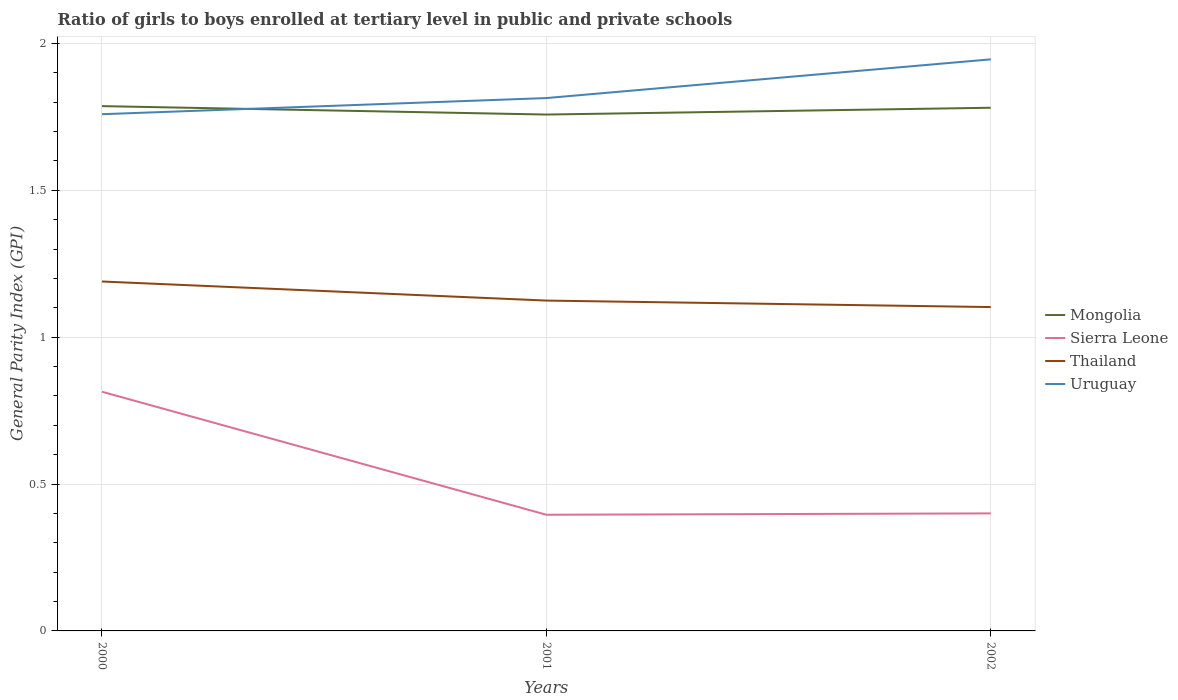How many different coloured lines are there?
Provide a succinct answer. 4. Does the line corresponding to Uruguay intersect with the line corresponding to Sierra Leone?
Offer a very short reply. No. Across all years, what is the maximum general parity index in Uruguay?
Your answer should be compact. 1.76. In which year was the general parity index in Sierra Leone maximum?
Make the answer very short. 2001. What is the total general parity index in Sierra Leone in the graph?
Provide a succinct answer. -0. What is the difference between the highest and the second highest general parity index in Uruguay?
Your answer should be compact. 0.19. What is the difference between the highest and the lowest general parity index in Thailand?
Your answer should be compact. 1. Is the general parity index in Sierra Leone strictly greater than the general parity index in Mongolia over the years?
Offer a terse response. Yes. How many lines are there?
Offer a terse response. 4. How many years are there in the graph?
Give a very brief answer. 3. Are the values on the major ticks of Y-axis written in scientific E-notation?
Make the answer very short. No. Does the graph contain grids?
Your answer should be very brief. Yes. What is the title of the graph?
Keep it short and to the point. Ratio of girls to boys enrolled at tertiary level in public and private schools. Does "Kazakhstan" appear as one of the legend labels in the graph?
Keep it short and to the point. No. What is the label or title of the Y-axis?
Ensure brevity in your answer.  General Parity Index (GPI). What is the General Parity Index (GPI) in Mongolia in 2000?
Make the answer very short. 1.79. What is the General Parity Index (GPI) of Sierra Leone in 2000?
Provide a succinct answer. 0.81. What is the General Parity Index (GPI) in Thailand in 2000?
Your answer should be very brief. 1.19. What is the General Parity Index (GPI) of Uruguay in 2000?
Ensure brevity in your answer.  1.76. What is the General Parity Index (GPI) in Mongolia in 2001?
Give a very brief answer. 1.76. What is the General Parity Index (GPI) in Sierra Leone in 2001?
Your answer should be very brief. 0.4. What is the General Parity Index (GPI) of Thailand in 2001?
Your answer should be very brief. 1.12. What is the General Parity Index (GPI) of Uruguay in 2001?
Make the answer very short. 1.81. What is the General Parity Index (GPI) of Mongolia in 2002?
Provide a short and direct response. 1.78. What is the General Parity Index (GPI) in Sierra Leone in 2002?
Make the answer very short. 0.4. What is the General Parity Index (GPI) in Thailand in 2002?
Ensure brevity in your answer.  1.1. What is the General Parity Index (GPI) in Uruguay in 2002?
Your answer should be very brief. 1.95. Across all years, what is the maximum General Parity Index (GPI) of Mongolia?
Offer a terse response. 1.79. Across all years, what is the maximum General Parity Index (GPI) in Sierra Leone?
Make the answer very short. 0.81. Across all years, what is the maximum General Parity Index (GPI) in Thailand?
Make the answer very short. 1.19. Across all years, what is the maximum General Parity Index (GPI) in Uruguay?
Provide a succinct answer. 1.95. Across all years, what is the minimum General Parity Index (GPI) in Mongolia?
Offer a terse response. 1.76. Across all years, what is the minimum General Parity Index (GPI) in Sierra Leone?
Provide a short and direct response. 0.4. Across all years, what is the minimum General Parity Index (GPI) in Thailand?
Offer a terse response. 1.1. Across all years, what is the minimum General Parity Index (GPI) in Uruguay?
Keep it short and to the point. 1.76. What is the total General Parity Index (GPI) of Mongolia in the graph?
Give a very brief answer. 5.32. What is the total General Parity Index (GPI) in Sierra Leone in the graph?
Give a very brief answer. 1.61. What is the total General Parity Index (GPI) of Thailand in the graph?
Provide a succinct answer. 3.42. What is the total General Parity Index (GPI) in Uruguay in the graph?
Your answer should be compact. 5.52. What is the difference between the General Parity Index (GPI) of Mongolia in 2000 and that in 2001?
Your answer should be compact. 0.03. What is the difference between the General Parity Index (GPI) in Sierra Leone in 2000 and that in 2001?
Provide a succinct answer. 0.42. What is the difference between the General Parity Index (GPI) of Thailand in 2000 and that in 2001?
Offer a very short reply. 0.06. What is the difference between the General Parity Index (GPI) of Uruguay in 2000 and that in 2001?
Your answer should be compact. -0.05. What is the difference between the General Parity Index (GPI) in Mongolia in 2000 and that in 2002?
Offer a terse response. 0.01. What is the difference between the General Parity Index (GPI) of Sierra Leone in 2000 and that in 2002?
Offer a very short reply. 0.41. What is the difference between the General Parity Index (GPI) in Thailand in 2000 and that in 2002?
Give a very brief answer. 0.09. What is the difference between the General Parity Index (GPI) of Uruguay in 2000 and that in 2002?
Provide a succinct answer. -0.19. What is the difference between the General Parity Index (GPI) in Mongolia in 2001 and that in 2002?
Ensure brevity in your answer.  -0.02. What is the difference between the General Parity Index (GPI) of Sierra Leone in 2001 and that in 2002?
Offer a terse response. -0. What is the difference between the General Parity Index (GPI) of Thailand in 2001 and that in 2002?
Ensure brevity in your answer.  0.02. What is the difference between the General Parity Index (GPI) in Uruguay in 2001 and that in 2002?
Provide a succinct answer. -0.13. What is the difference between the General Parity Index (GPI) in Mongolia in 2000 and the General Parity Index (GPI) in Sierra Leone in 2001?
Your answer should be compact. 1.39. What is the difference between the General Parity Index (GPI) of Mongolia in 2000 and the General Parity Index (GPI) of Thailand in 2001?
Ensure brevity in your answer.  0.66. What is the difference between the General Parity Index (GPI) in Mongolia in 2000 and the General Parity Index (GPI) in Uruguay in 2001?
Provide a short and direct response. -0.03. What is the difference between the General Parity Index (GPI) in Sierra Leone in 2000 and the General Parity Index (GPI) in Thailand in 2001?
Ensure brevity in your answer.  -0.31. What is the difference between the General Parity Index (GPI) of Sierra Leone in 2000 and the General Parity Index (GPI) of Uruguay in 2001?
Your answer should be very brief. -1. What is the difference between the General Parity Index (GPI) of Thailand in 2000 and the General Parity Index (GPI) of Uruguay in 2001?
Make the answer very short. -0.62. What is the difference between the General Parity Index (GPI) of Mongolia in 2000 and the General Parity Index (GPI) of Sierra Leone in 2002?
Ensure brevity in your answer.  1.39. What is the difference between the General Parity Index (GPI) of Mongolia in 2000 and the General Parity Index (GPI) of Thailand in 2002?
Make the answer very short. 0.68. What is the difference between the General Parity Index (GPI) in Mongolia in 2000 and the General Parity Index (GPI) in Uruguay in 2002?
Make the answer very short. -0.16. What is the difference between the General Parity Index (GPI) of Sierra Leone in 2000 and the General Parity Index (GPI) of Thailand in 2002?
Ensure brevity in your answer.  -0.29. What is the difference between the General Parity Index (GPI) of Sierra Leone in 2000 and the General Parity Index (GPI) of Uruguay in 2002?
Make the answer very short. -1.13. What is the difference between the General Parity Index (GPI) of Thailand in 2000 and the General Parity Index (GPI) of Uruguay in 2002?
Your answer should be very brief. -0.76. What is the difference between the General Parity Index (GPI) of Mongolia in 2001 and the General Parity Index (GPI) of Sierra Leone in 2002?
Your response must be concise. 1.36. What is the difference between the General Parity Index (GPI) of Mongolia in 2001 and the General Parity Index (GPI) of Thailand in 2002?
Offer a very short reply. 0.66. What is the difference between the General Parity Index (GPI) of Mongolia in 2001 and the General Parity Index (GPI) of Uruguay in 2002?
Provide a short and direct response. -0.19. What is the difference between the General Parity Index (GPI) of Sierra Leone in 2001 and the General Parity Index (GPI) of Thailand in 2002?
Give a very brief answer. -0.71. What is the difference between the General Parity Index (GPI) of Sierra Leone in 2001 and the General Parity Index (GPI) of Uruguay in 2002?
Offer a very short reply. -1.55. What is the difference between the General Parity Index (GPI) in Thailand in 2001 and the General Parity Index (GPI) in Uruguay in 2002?
Your answer should be compact. -0.82. What is the average General Parity Index (GPI) in Mongolia per year?
Ensure brevity in your answer.  1.77. What is the average General Parity Index (GPI) of Sierra Leone per year?
Offer a terse response. 0.54. What is the average General Parity Index (GPI) of Thailand per year?
Your response must be concise. 1.14. What is the average General Parity Index (GPI) of Uruguay per year?
Give a very brief answer. 1.84. In the year 2000, what is the difference between the General Parity Index (GPI) of Mongolia and General Parity Index (GPI) of Sierra Leone?
Your answer should be compact. 0.97. In the year 2000, what is the difference between the General Parity Index (GPI) in Mongolia and General Parity Index (GPI) in Thailand?
Offer a terse response. 0.6. In the year 2000, what is the difference between the General Parity Index (GPI) in Mongolia and General Parity Index (GPI) in Uruguay?
Offer a very short reply. 0.03. In the year 2000, what is the difference between the General Parity Index (GPI) in Sierra Leone and General Parity Index (GPI) in Thailand?
Your answer should be very brief. -0.38. In the year 2000, what is the difference between the General Parity Index (GPI) in Sierra Leone and General Parity Index (GPI) in Uruguay?
Provide a short and direct response. -0.94. In the year 2000, what is the difference between the General Parity Index (GPI) in Thailand and General Parity Index (GPI) in Uruguay?
Your response must be concise. -0.57. In the year 2001, what is the difference between the General Parity Index (GPI) in Mongolia and General Parity Index (GPI) in Sierra Leone?
Make the answer very short. 1.36. In the year 2001, what is the difference between the General Parity Index (GPI) of Mongolia and General Parity Index (GPI) of Thailand?
Offer a very short reply. 0.63. In the year 2001, what is the difference between the General Parity Index (GPI) in Mongolia and General Parity Index (GPI) in Uruguay?
Your answer should be compact. -0.06. In the year 2001, what is the difference between the General Parity Index (GPI) of Sierra Leone and General Parity Index (GPI) of Thailand?
Offer a very short reply. -0.73. In the year 2001, what is the difference between the General Parity Index (GPI) in Sierra Leone and General Parity Index (GPI) in Uruguay?
Provide a short and direct response. -1.42. In the year 2001, what is the difference between the General Parity Index (GPI) in Thailand and General Parity Index (GPI) in Uruguay?
Give a very brief answer. -0.69. In the year 2002, what is the difference between the General Parity Index (GPI) in Mongolia and General Parity Index (GPI) in Sierra Leone?
Offer a very short reply. 1.38. In the year 2002, what is the difference between the General Parity Index (GPI) in Mongolia and General Parity Index (GPI) in Thailand?
Your response must be concise. 0.68. In the year 2002, what is the difference between the General Parity Index (GPI) in Mongolia and General Parity Index (GPI) in Uruguay?
Your answer should be very brief. -0.16. In the year 2002, what is the difference between the General Parity Index (GPI) in Sierra Leone and General Parity Index (GPI) in Thailand?
Your response must be concise. -0.7. In the year 2002, what is the difference between the General Parity Index (GPI) of Sierra Leone and General Parity Index (GPI) of Uruguay?
Keep it short and to the point. -1.55. In the year 2002, what is the difference between the General Parity Index (GPI) in Thailand and General Parity Index (GPI) in Uruguay?
Make the answer very short. -0.84. What is the ratio of the General Parity Index (GPI) in Mongolia in 2000 to that in 2001?
Provide a succinct answer. 1.02. What is the ratio of the General Parity Index (GPI) of Sierra Leone in 2000 to that in 2001?
Your answer should be very brief. 2.06. What is the ratio of the General Parity Index (GPI) of Thailand in 2000 to that in 2001?
Keep it short and to the point. 1.06. What is the ratio of the General Parity Index (GPI) of Uruguay in 2000 to that in 2001?
Offer a very short reply. 0.97. What is the ratio of the General Parity Index (GPI) of Sierra Leone in 2000 to that in 2002?
Make the answer very short. 2.04. What is the ratio of the General Parity Index (GPI) of Thailand in 2000 to that in 2002?
Make the answer very short. 1.08. What is the ratio of the General Parity Index (GPI) in Uruguay in 2000 to that in 2002?
Your answer should be compact. 0.9. What is the ratio of the General Parity Index (GPI) of Mongolia in 2001 to that in 2002?
Provide a short and direct response. 0.99. What is the ratio of the General Parity Index (GPI) of Thailand in 2001 to that in 2002?
Offer a very short reply. 1.02. What is the ratio of the General Parity Index (GPI) of Uruguay in 2001 to that in 2002?
Your response must be concise. 0.93. What is the difference between the highest and the second highest General Parity Index (GPI) in Mongolia?
Provide a short and direct response. 0.01. What is the difference between the highest and the second highest General Parity Index (GPI) in Sierra Leone?
Your answer should be compact. 0.41. What is the difference between the highest and the second highest General Parity Index (GPI) in Thailand?
Your response must be concise. 0.06. What is the difference between the highest and the second highest General Parity Index (GPI) of Uruguay?
Your answer should be very brief. 0.13. What is the difference between the highest and the lowest General Parity Index (GPI) of Mongolia?
Offer a very short reply. 0.03. What is the difference between the highest and the lowest General Parity Index (GPI) of Sierra Leone?
Make the answer very short. 0.42. What is the difference between the highest and the lowest General Parity Index (GPI) of Thailand?
Give a very brief answer. 0.09. What is the difference between the highest and the lowest General Parity Index (GPI) in Uruguay?
Provide a short and direct response. 0.19. 